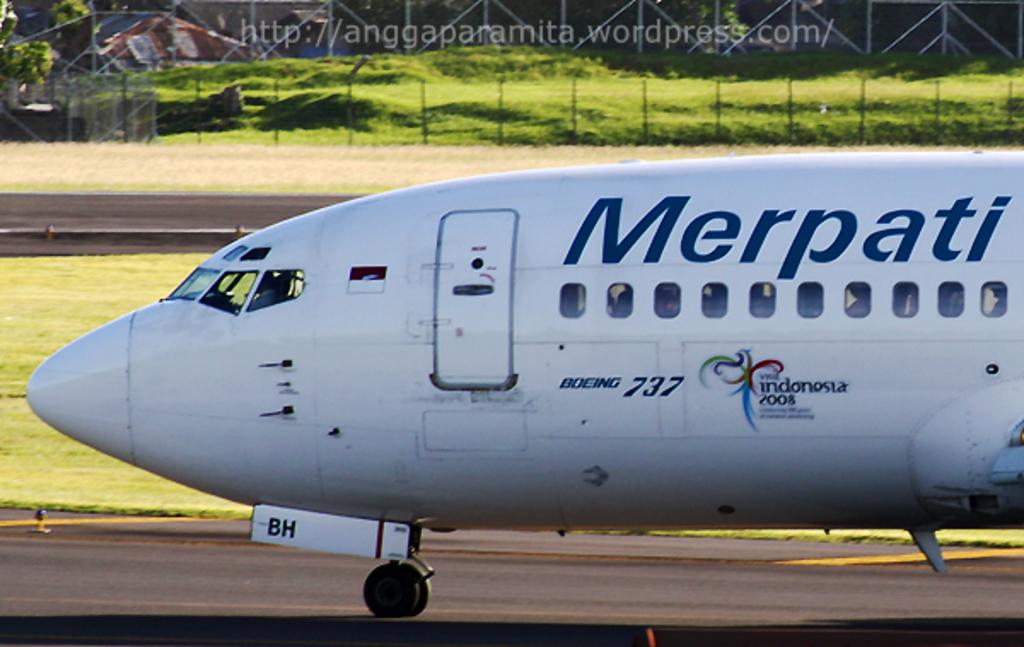What is the unusual object on the road in the image? There is an airplane on the road in the image. What type of vegetation can be seen in the image? There is grass in the image. What structure is present in the image? There is a fence in the image. What can be seen in the distance in the image? There are trees visible in the background. What type of fish can be seen swimming in the grass in the image? There are no fish present in the image, and the grass is not a body of water where fish could swim. 